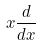<formula> <loc_0><loc_0><loc_500><loc_500>x \frac { d } { d x }</formula> 